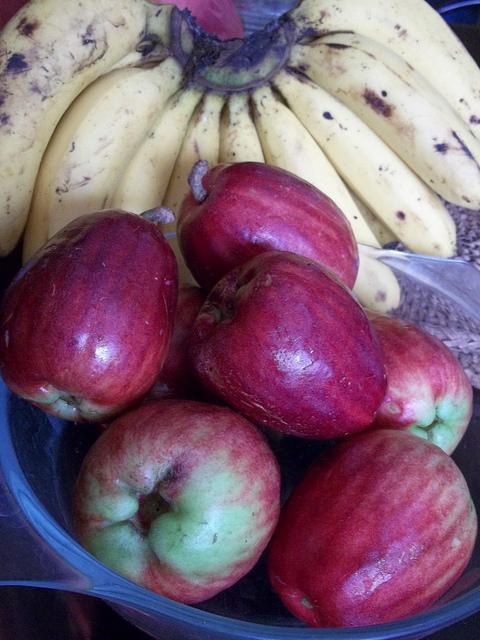Which country grows most bananas?
Indicate the correct response and explain using: 'Answer: answer
Rationale: rationale.'
Options: Nepal, india, us, china. Answer: india.
Rationale: Bananas are grown in india. 